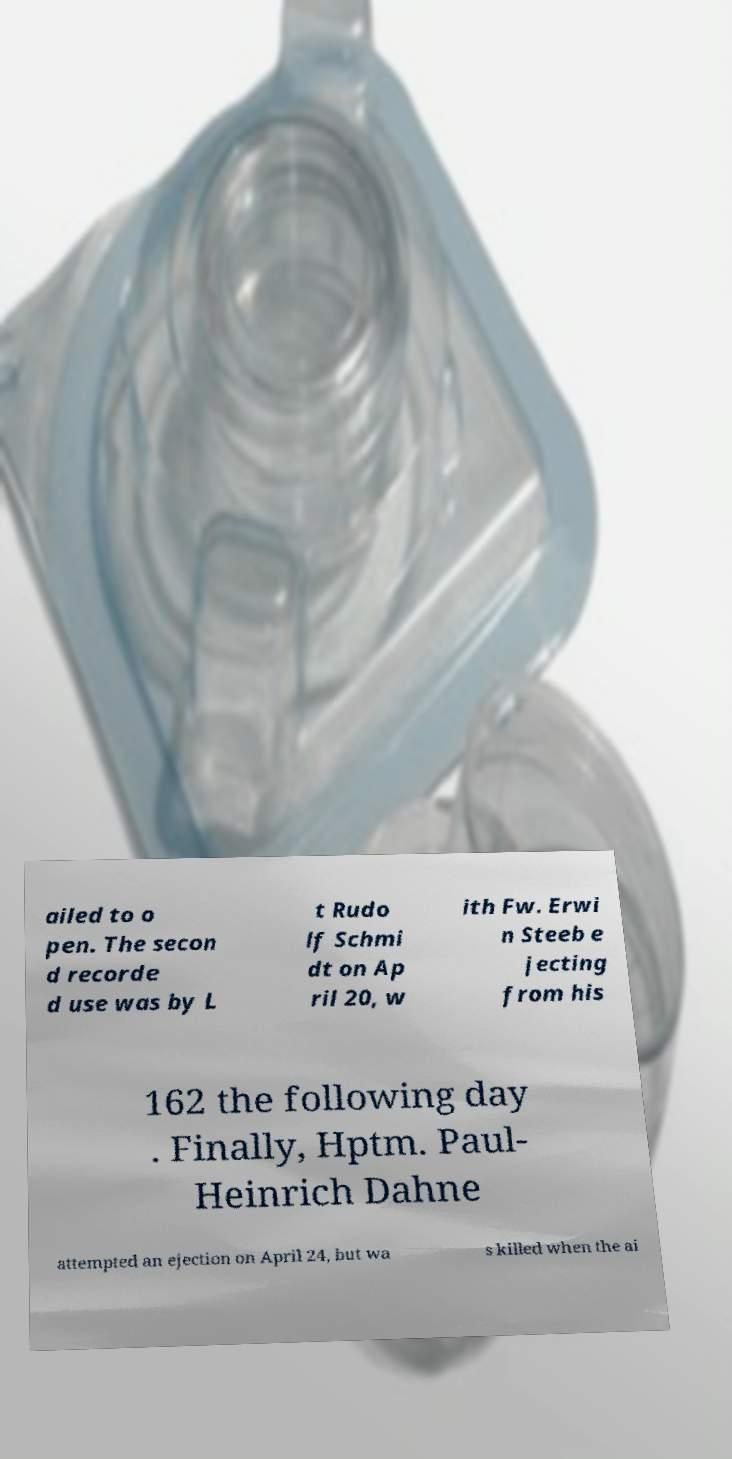What messages or text are displayed in this image? I need them in a readable, typed format. ailed to o pen. The secon d recorde d use was by L t Rudo lf Schmi dt on Ap ril 20, w ith Fw. Erwi n Steeb e jecting from his 162 the following day . Finally, Hptm. Paul- Heinrich Dahne attempted an ejection on April 24, but wa s killed when the ai 